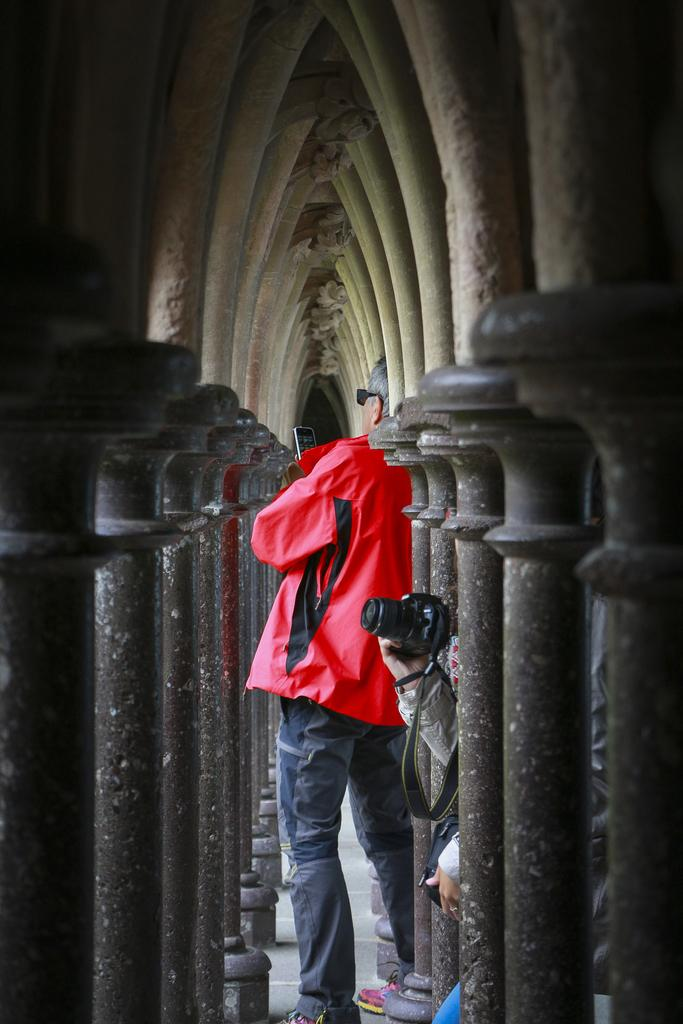What is the main subject of the image? There is a person in the image. Can you describe the person's position in the image? The person is standing in between pillars. What type of degree is the person holding in the image? There is no degree visible in the image; the person is standing in between pillars. How many cakes are on the table next to the person in the image? There is no table or cakes present in the image; it only shows a person standing between pillars. 